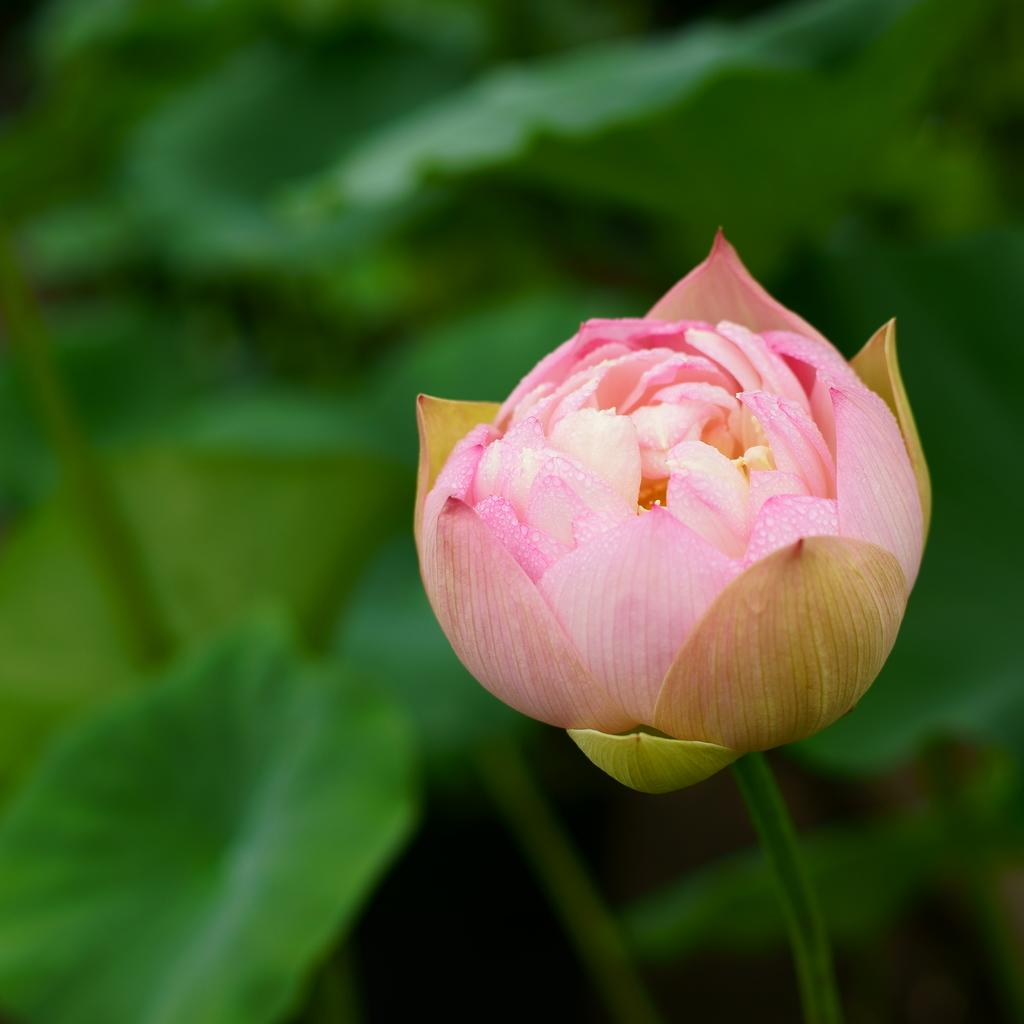What is the main subject of the image? There is a flower in the image. Can you describe the background of the image? The background of the image is blurred. How does the flower attract attention in the image? The flower does not actively attract attention in the image; it is simply present. Can you hear a sneeze or horn in the image? There is no sound present in the image, so it is not possible to hear a sneeze or horn. 